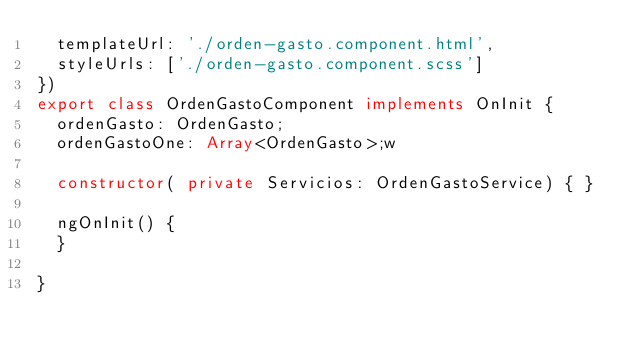Convert code to text. <code><loc_0><loc_0><loc_500><loc_500><_TypeScript_>  templateUrl: './orden-gasto.component.html',
  styleUrls: ['./orden-gasto.component.scss']
})
export class OrdenGastoComponent implements OnInit {
  ordenGasto: OrdenGasto;
  ordenGastoOne: Array<OrdenGasto>;w

  constructor( private Servicios: OrdenGastoService) { }

  ngOnInit() {
  }

}
</code> 